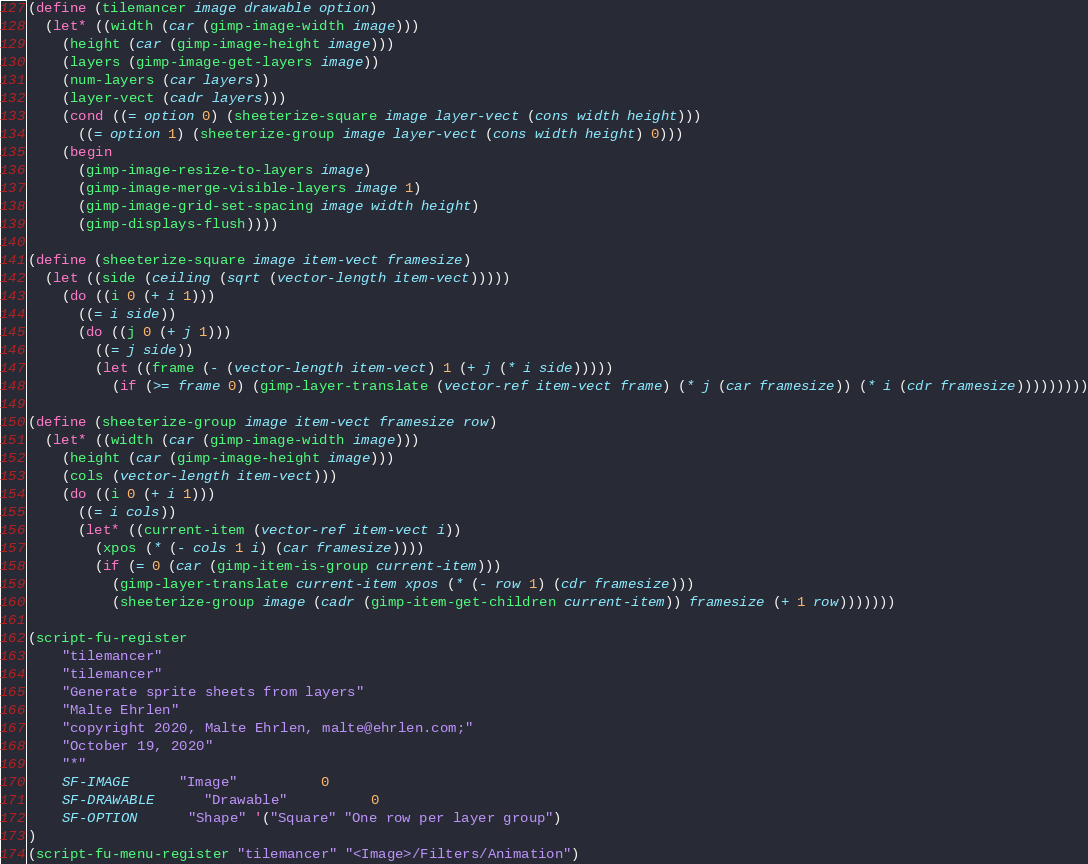Convert code to text. <code><loc_0><loc_0><loc_500><loc_500><_Scheme_>(define (tilemancer image drawable option)
  (let* ((width (car (gimp-image-width image)))
    (height (car (gimp-image-height image)))
    (layers (gimp-image-get-layers image))
    (num-layers (car layers))
    (layer-vect (cadr layers)))
    (cond ((= option 0) (sheeterize-square image layer-vect (cons width height)))
      ((= option 1) (sheeterize-group image layer-vect (cons width height) 0)))
    (begin
      (gimp-image-resize-to-layers image)
      (gimp-image-merge-visible-layers image 1)
      (gimp-image-grid-set-spacing image width height)
      (gimp-displays-flush))))

(define (sheeterize-square image item-vect framesize)
  (let ((side (ceiling (sqrt (vector-length item-vect)))))
    (do ((i 0 (+ i 1)))
      ((= i side))
      (do ((j 0 (+ j 1))) 
        ((= j side)) 
        (let ((frame (- (vector-length item-vect) 1 (+ j (* i side)))))
          (if (>= frame 0) (gimp-layer-translate (vector-ref item-vect frame) (* j (car framesize)) (* i (cdr framesize)))))))))

(define (sheeterize-group image item-vect framesize row)
  (let* ((width (car (gimp-image-width image)))
    (height (car (gimp-image-height image)))
    (cols (vector-length item-vect))) 
    (do ((i 0 (+ i 1))) 
      ((= i cols)) 
      (let* ((current-item (vector-ref item-vect i))
        (xpos (* (- cols 1 i) (car framesize))))
        (if (= 0 (car (gimp-item-is-group current-item)))
          (gimp-layer-translate current-item xpos (* (- row 1) (cdr framesize)))
          (sheeterize-group image (cadr (gimp-item-get-children current-item)) framesize (+ 1 row)))))))

(script-fu-register
    "tilemancer"
    "tilemancer"
    "Generate sprite sheets from layers"
    "Malte Ehrlen"
    "copyright 2020, Malte Ehrlen, malte@ehrlen.com;"
    "October 19, 2020"
    "*"
    SF-IMAGE      "Image"          0
    SF-DRAWABLE      "Drawable"          0
    SF-OPTION      "Shape" '("Square" "One row per layer group")
)
(script-fu-menu-register "tilemancer" "<Image>/Filters/Animation")
</code> 